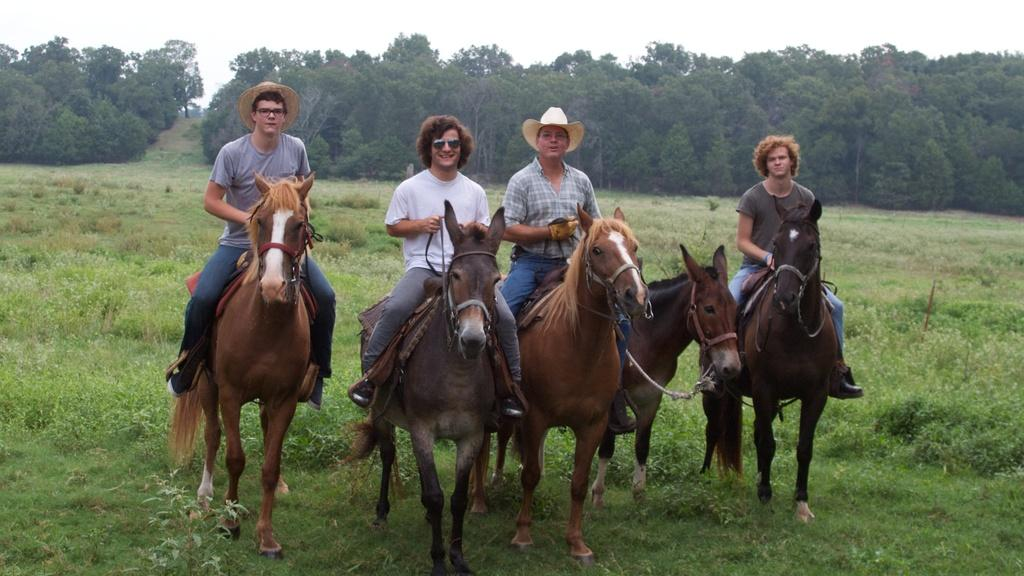How many people are in the image? There are four people in the image. What are the people doing in the image? Each person is sitting on a horse. What type of terrain is visible in the image? There is grass visible in the image. What other types of vegetation can be seen in the image? There are plants and trees in the image. What is visible in the background of the image? The sky is visible in the background of the image. What shape is the tub in the image? There is no tub present in the image. What type of smoke can be seen coming from the trees in the image? There is no smoke visible in the image; only trees and the sky are present in the background. 